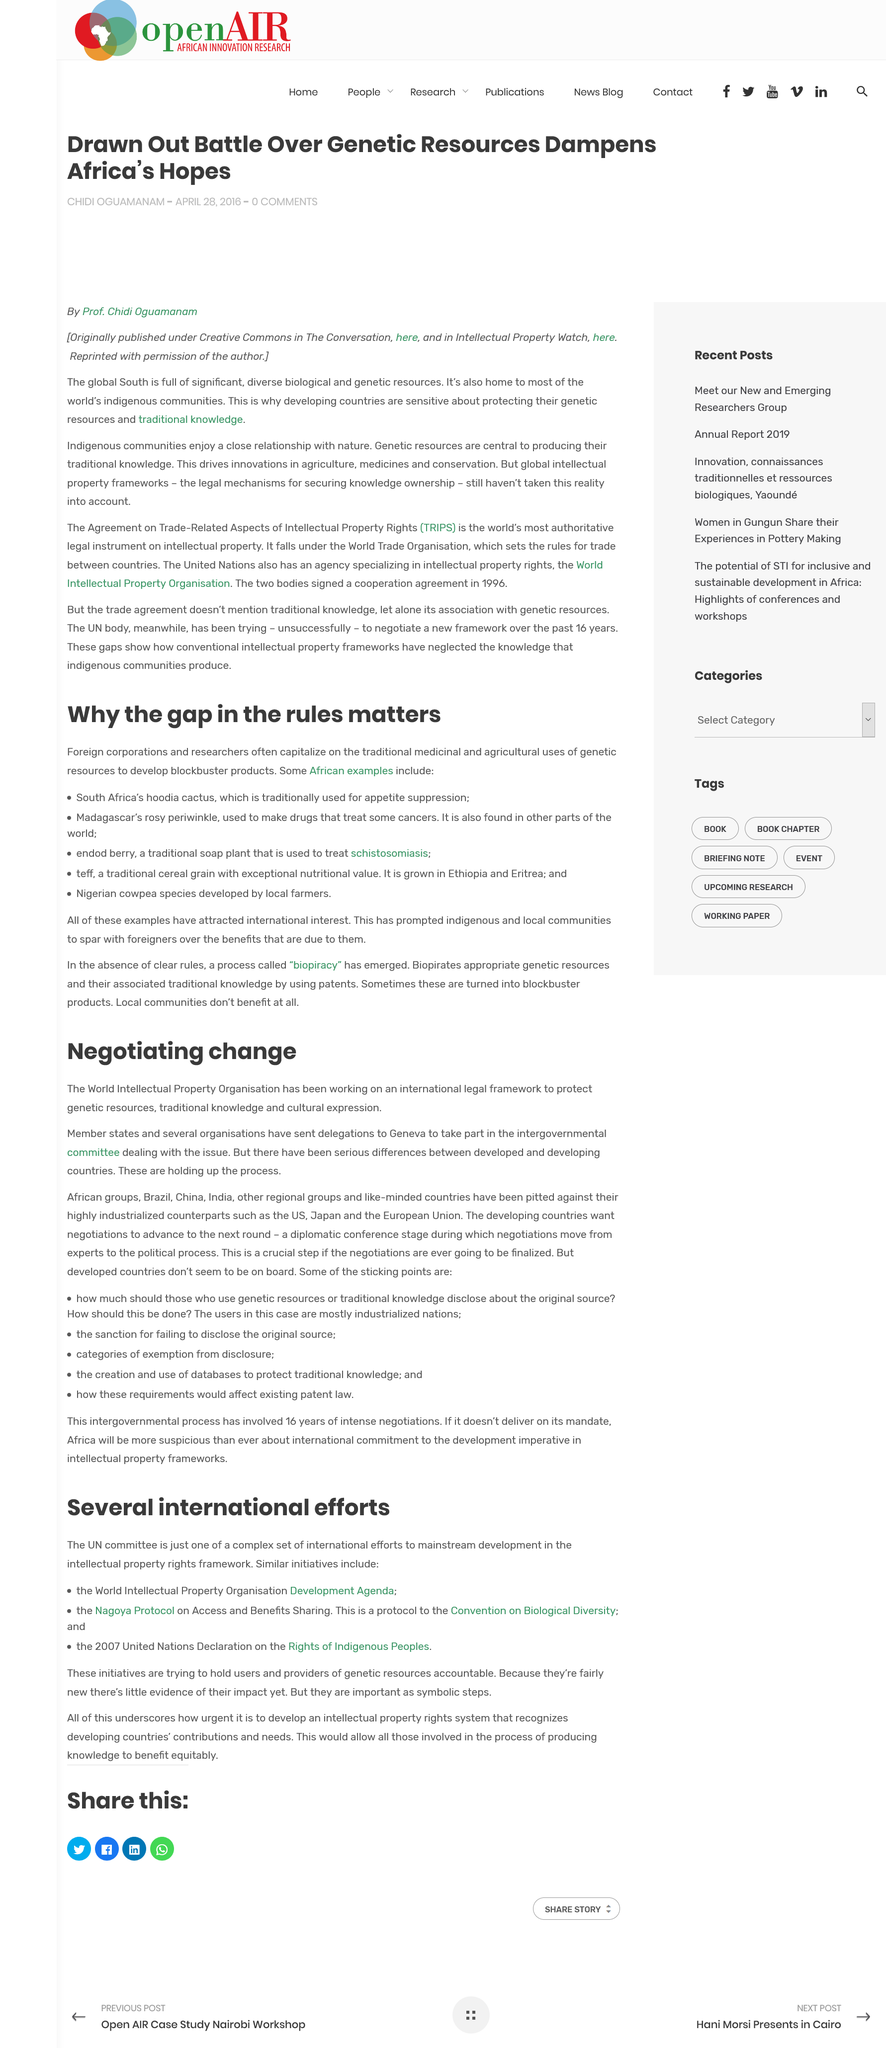Indicate a few pertinent items in this graphic. It has been the World Intellectual Property Organization that has been working on the legal framework. The legal framework protects genetic resources, traditional knowledge, and cultural expression, and ensures that these valuable assets are conserved and used in a sustainable and equitable manner. Delegations have been sent to Geneva. 